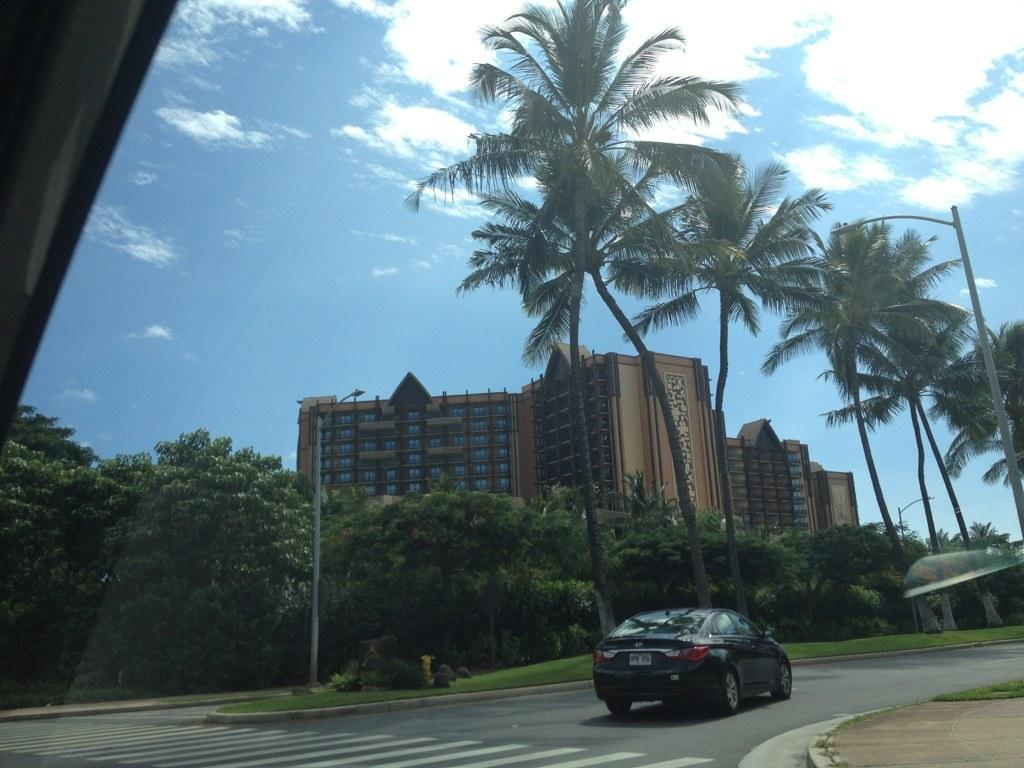What is the main subject of the image? There is a car on the road in the image. What can be seen in the background of the image? There is a building, trees, a pole, and the sky visible in the background of the image. What is the condition of the sky in the image? The sky is visible in the background of the image, and there are clouds present. Can you see any fairies flying around the car in the image? There are no fairies present in the image. What type of current is flowing through the car's engine in the image? The image does not provide information about the car's engine or any current flowing through it. 